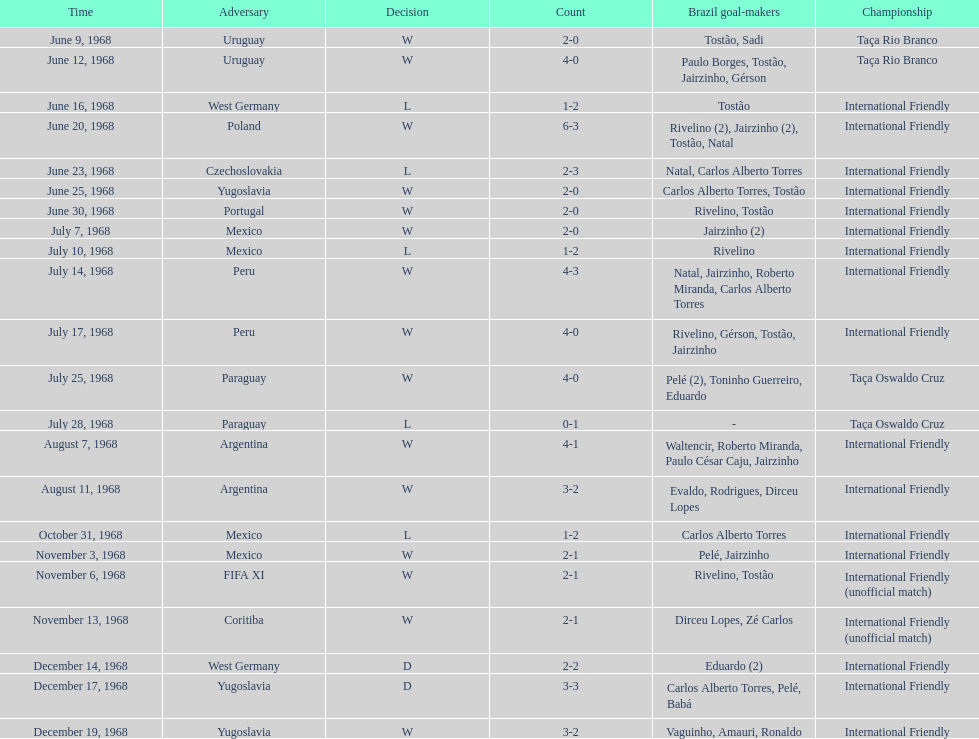What is the number of countries they have played? 11. 